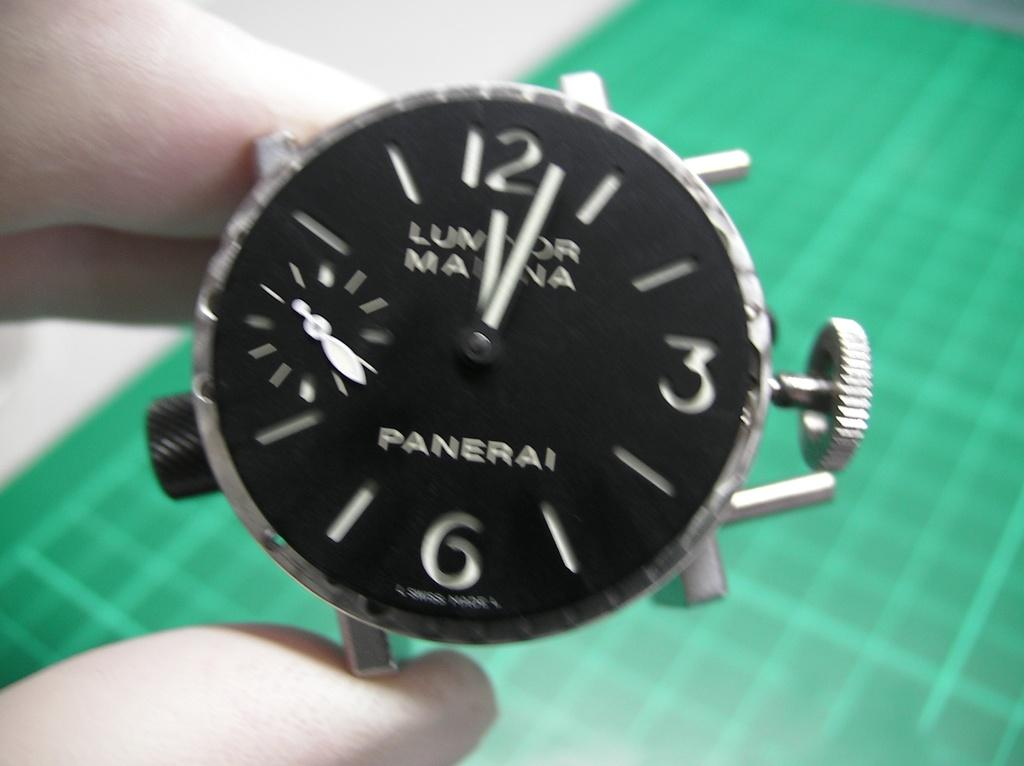<image>
Describe the image concisely. Someone holding a black watch face which states PANERAI 